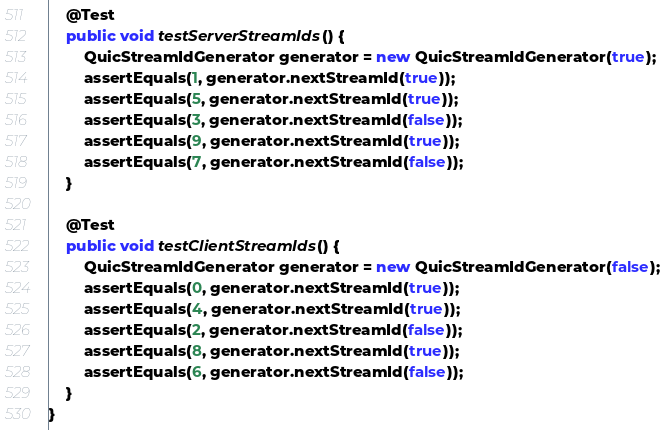<code> <loc_0><loc_0><loc_500><loc_500><_Java_>
    @Test
    public void testServerStreamIds() {
        QuicStreamIdGenerator generator = new QuicStreamIdGenerator(true);
        assertEquals(1, generator.nextStreamId(true));
        assertEquals(5, generator.nextStreamId(true));
        assertEquals(3, generator.nextStreamId(false));
        assertEquals(9, generator.nextStreamId(true));
        assertEquals(7, generator.nextStreamId(false));
    }

    @Test
    public void testClientStreamIds() {
        QuicStreamIdGenerator generator = new QuicStreamIdGenerator(false);
        assertEquals(0, generator.nextStreamId(true));
        assertEquals(4, generator.nextStreamId(true));
        assertEquals(2, generator.nextStreamId(false));
        assertEquals(8, generator.nextStreamId(true));
        assertEquals(6, generator.nextStreamId(false));
    }
}
</code> 